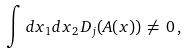<formula> <loc_0><loc_0><loc_500><loc_500>\int d x _ { 1 } d x _ { 2 } \, D _ { j } ( A ( x ) ) \, \neq \, 0 \, ,</formula> 